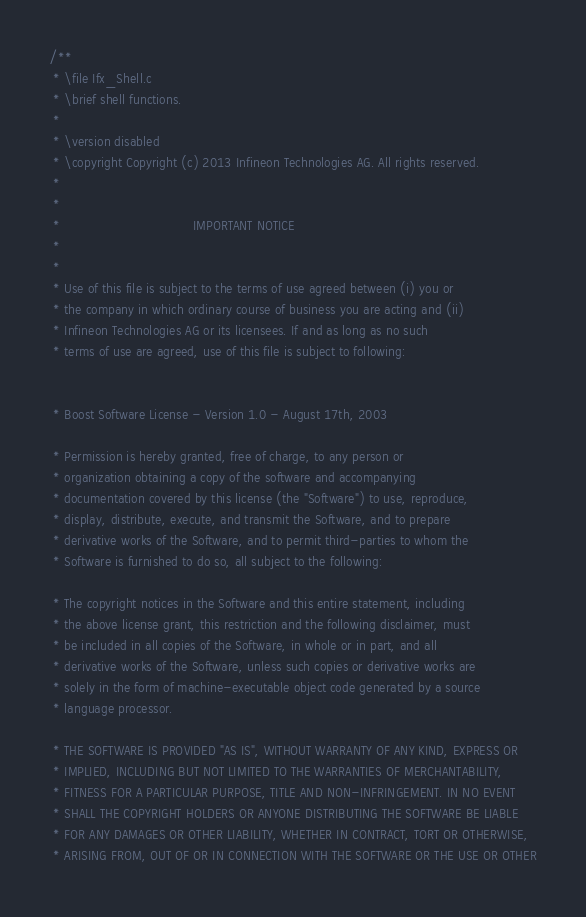Convert code to text. <code><loc_0><loc_0><loc_500><loc_500><_C_>/**
 * \file Ifx_Shell.c
 * \brief shell functions.
 *
 * \version disabled
 * \copyright Copyright (c) 2013 Infineon Technologies AG. All rights reserved.
 *
 *
 *                                 IMPORTANT NOTICE
 *
 *
 * Use of this file is subject to the terms of use agreed between (i) you or 
 * the company in which ordinary course of business you are acting and (ii) 
 * Infineon Technologies AG or its licensees. If and as long as no such 
 * terms of use are agreed, use of this file is subject to following:


 * Boost Software License - Version 1.0 - August 17th, 2003

 * Permission is hereby granted, free of charge, to any person or 
 * organization obtaining a copy of the software and accompanying 
 * documentation covered by this license (the "Software") to use, reproduce,
 * display, distribute, execute, and transmit the Software, and to prepare
 * derivative works of the Software, and to permit third-parties to whom the 
 * Software is furnished to do so, all subject to the following:

 * The copyright notices in the Software and this entire statement, including
 * the above license grant, this restriction and the following disclaimer, must
 * be included in all copies of the Software, in whole or in part, and all
 * derivative works of the Software, unless such copies or derivative works are
 * solely in the form of machine-executable object code generated by a source
 * language processor.

 * THE SOFTWARE IS PROVIDED "AS IS", WITHOUT WARRANTY OF ANY KIND, EXPRESS OR 
 * IMPLIED, INCLUDING BUT NOT LIMITED TO THE WARRANTIES OF MERCHANTABILITY,
 * FITNESS FOR A PARTICULAR PURPOSE, TITLE AND NON-INFRINGEMENT. IN NO EVENT
 * SHALL THE COPYRIGHT HOLDERS OR ANYONE DISTRIBUTING THE SOFTWARE BE LIABLE 
 * FOR ANY DAMAGES OR OTHER LIABILITY, WHETHER IN CONTRACT, TORT OR OTHERWISE,
 * ARISING FROM, OUT OF OR IN CONNECTION WITH THE SOFTWARE OR THE USE OR OTHER</code> 